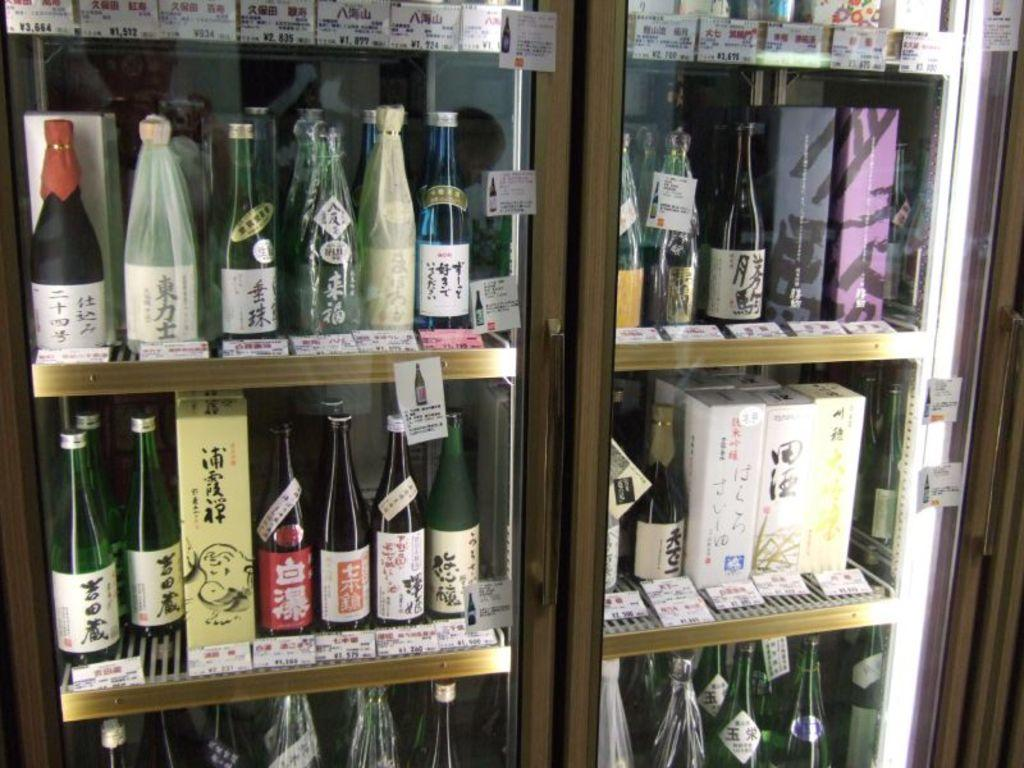What types of objects can be seen in the image? There are bottles, boxes, name boards, and bags in the image. How are the objects arranged in the image? The items are placed in racks. Are there any specific features on the bottles? Some bottles have covers on them. What additional elements can be found in the image? There are tags in the image. What type of dolls can be seen in the image? There are no dolls present in the image. What letters are being exchanged between the people in the image? There is no indication of people or letter exchange in the image; it primarily features objects placed in racks. 